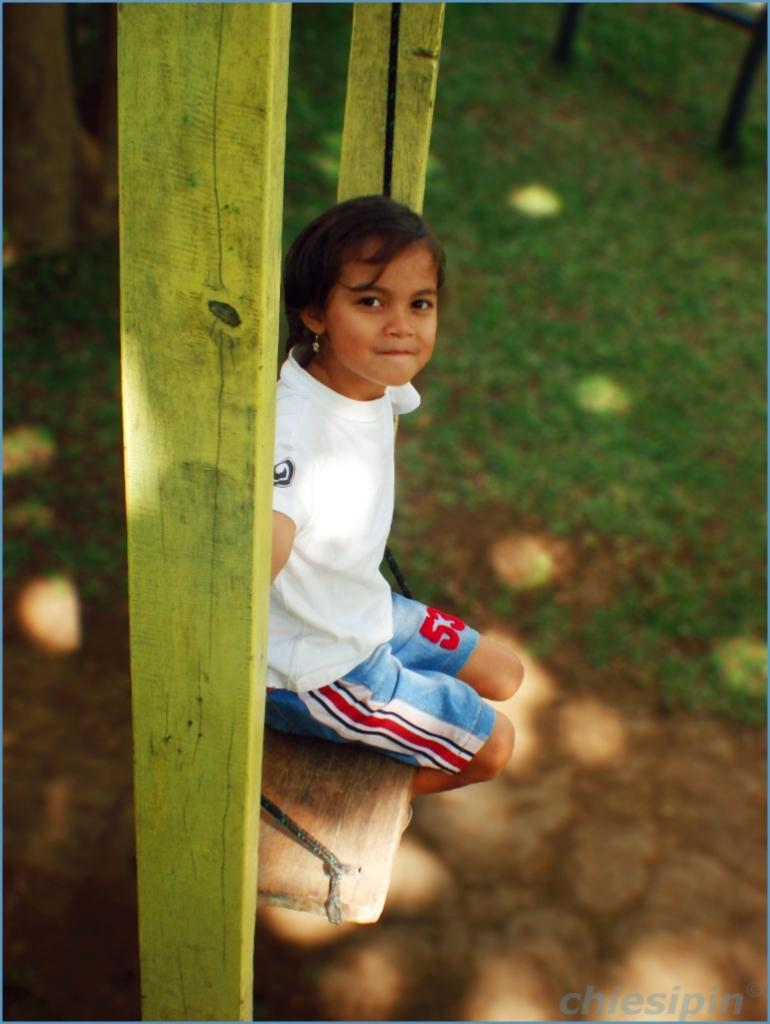<image>
Describe the image concisely. A little girl in blue shorts with a red 53 on them. 